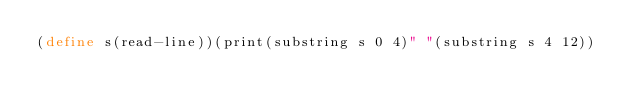Convert code to text. <code><loc_0><loc_0><loc_500><loc_500><_Scheme_>(define s(read-line))(print(substring s 0 4)" "(substring s 4 12))</code> 